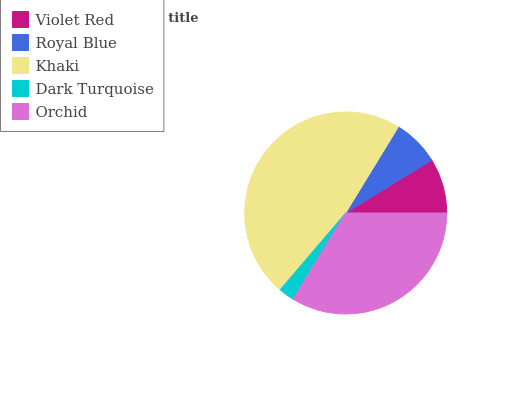Is Dark Turquoise the minimum?
Answer yes or no. Yes. Is Khaki the maximum?
Answer yes or no. Yes. Is Royal Blue the minimum?
Answer yes or no. No. Is Royal Blue the maximum?
Answer yes or no. No. Is Violet Red greater than Royal Blue?
Answer yes or no. Yes. Is Royal Blue less than Violet Red?
Answer yes or no. Yes. Is Royal Blue greater than Violet Red?
Answer yes or no. No. Is Violet Red less than Royal Blue?
Answer yes or no. No. Is Violet Red the high median?
Answer yes or no. Yes. Is Violet Red the low median?
Answer yes or no. Yes. Is Khaki the high median?
Answer yes or no. No. Is Orchid the low median?
Answer yes or no. No. 